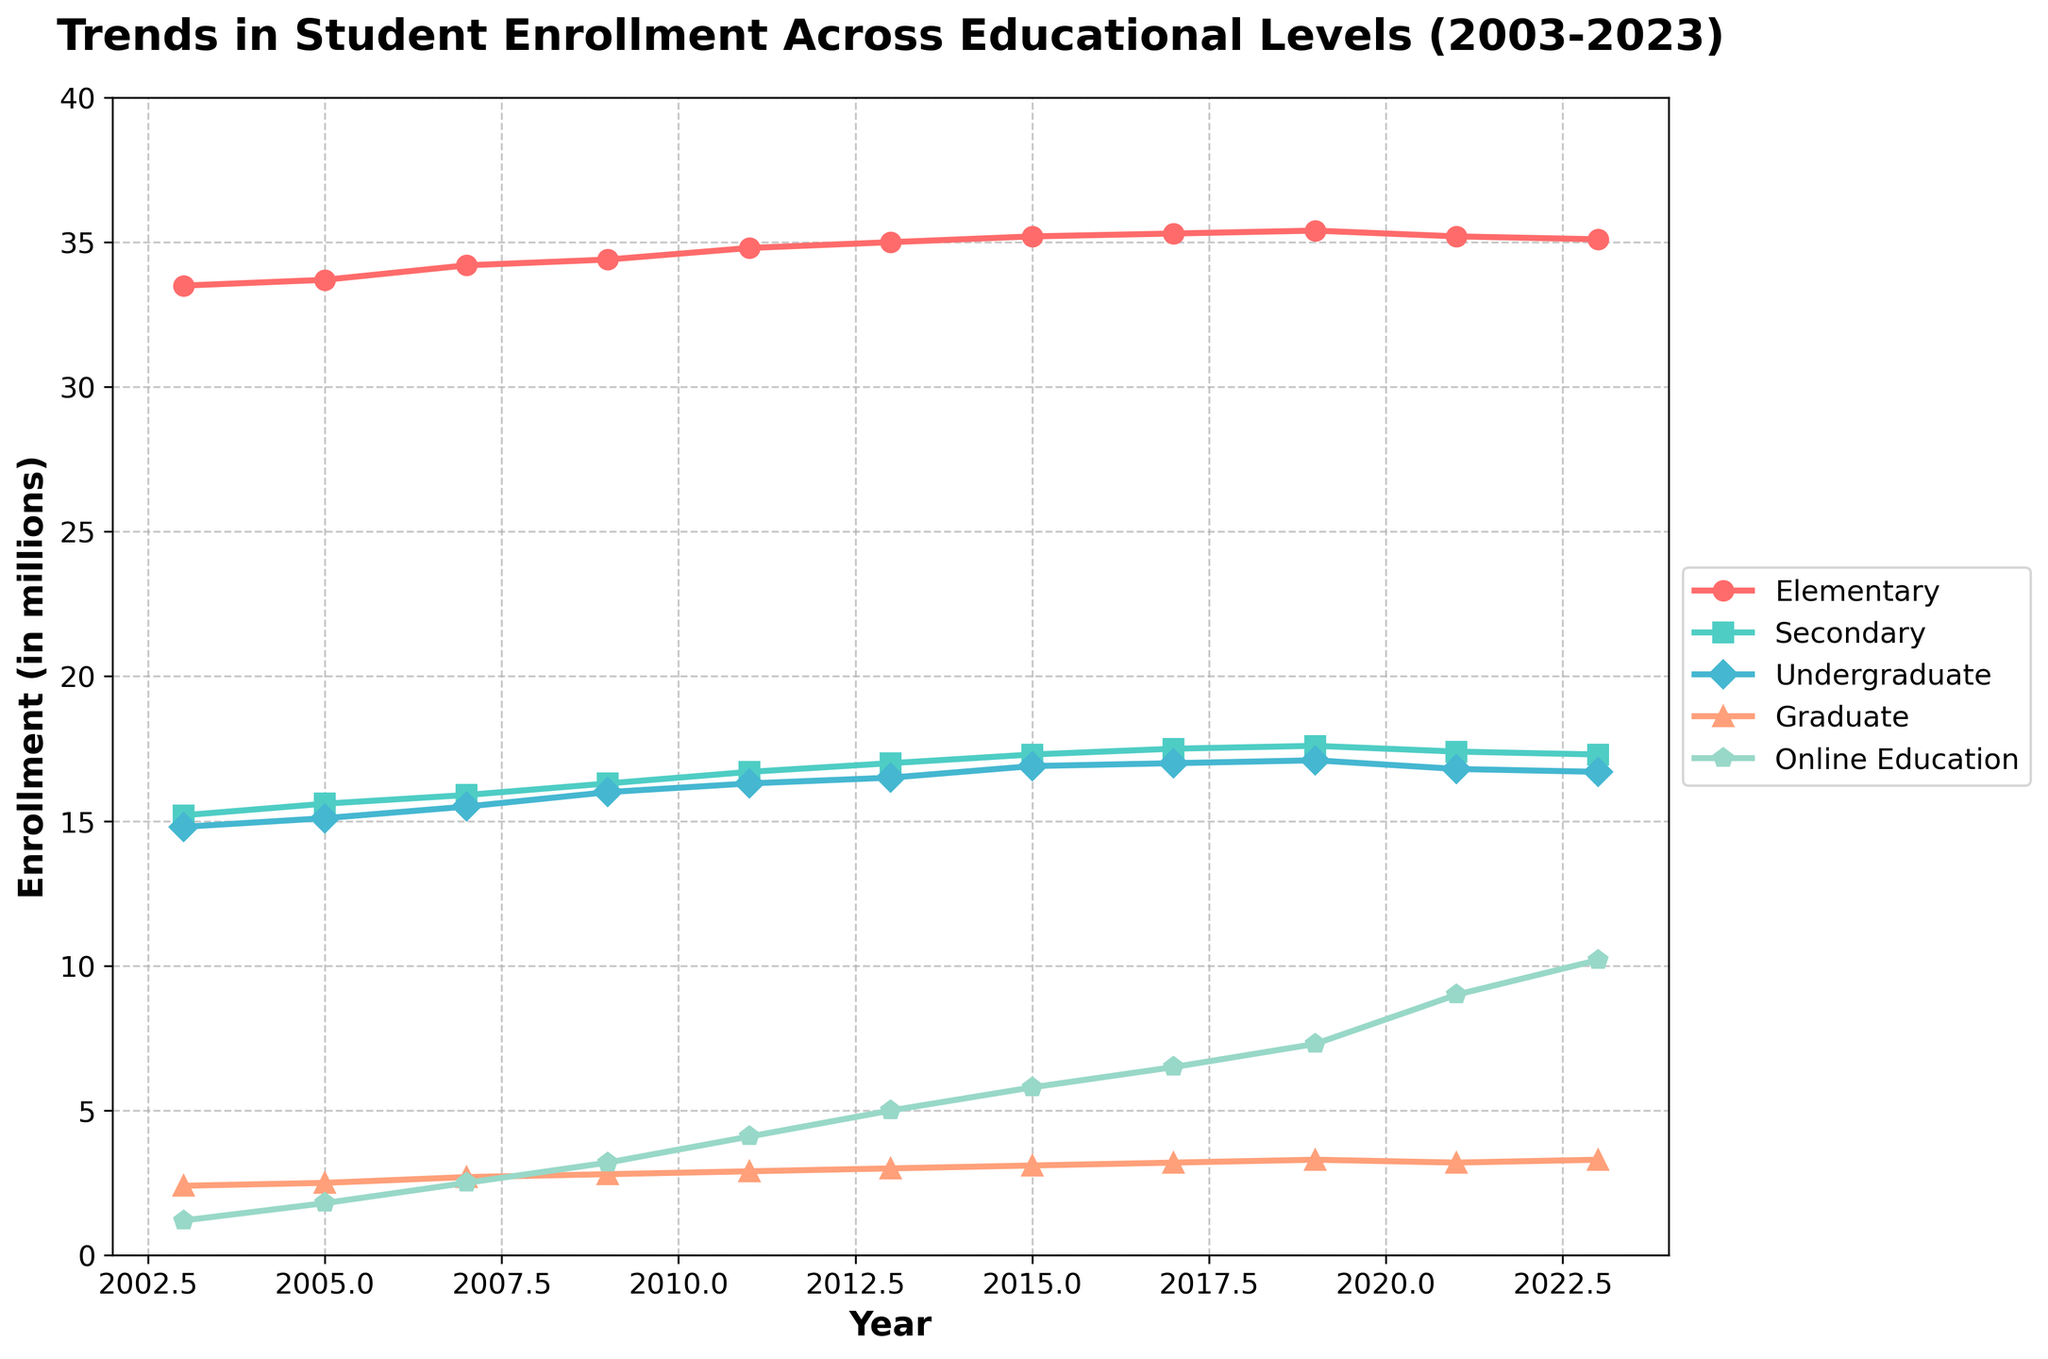Which enrollment category had the highest increase from 2003 to 2023? By observing the vertical distances between the starting point (2003) and ending point (2023) for each category, the Online Education category shows the most considerable increase.
Answer: Online Education What is the difference in enrollment numbers between Elementary and Graduate levels in 2023? From the 2023 data point, the Elementary enrollment is 35.1 million and the Graduate enrollment is 3.3 million. Subtracting Graduate from Elementary: 35.1 - 3.3 = 31.8
Answer: 31.8 Which educational level saw the least change in enrollment over the 20 years? By examining the lines, the Elementary level shows the least vertical change between 2003 and 2023.
Answer: Elementary In 2021, which category had the highest enrollment? Observing the 2021 data points, the Elementary category reaches the highest point.
Answer: Elementary What is the average enrollment for Secondary education from 2003 to 2023? Sum the enrollments for Secondary education (15.2+15.6+15.9+16.3+16.7+17.0+17.3+17.5+17.6+17.4+17.3) to get 181.8; then divide by 11, which gives an approximate average of 16.53.
Answer: 16.53 How did the enrollment for Undergraduate education change from 2003 to 2015? The Undergraduate enrollment in 2003 is 14.8 million, and in 2015 it is 16.9 million. The difference is 16.9 - 14.8 = 2.1
Answer: Increased by 2.1 Which year showed the first noticeable increase in Online Education enrollment? The graph shows a more noticeable upward trend starting around 2009.
Answer: 2009 Between 2011 and 2013, how much did the Graduate enrollment grow? Graduate enrollment in 2011 is 2.9 million, and in 2013 it is 3.0 million. The growth is 3.0 - 2.9 = 0.1
Answer: 0.1 Which educational level had relatively stable growth over the 20 years? By observing the smoothness and steadiness of the lines, the Secondary level demonstrates relatively stable growth.
Answer: Secondary Compare the growth rates of Graduate and Online Education from 2009 to 2023. Graduate education went from 2.8 million in 2009 to 3.3 million in 2023 (an increase of 0.5), while Online Education went from 3.2 million in 2009 to 10.2 million in 2023 (an increase of 7.0). Online Education has a significantly higher growth rate.
Answer: Online Education 